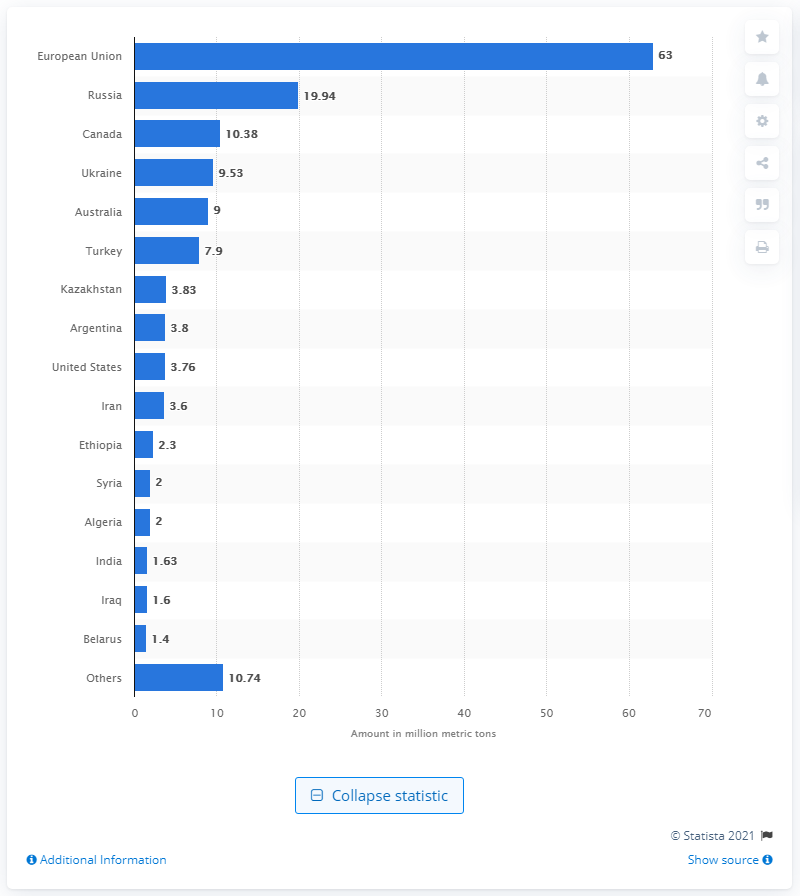Highlight a few significant elements in this photo. In the 2019/2020 crop year, Argentina produced a total of 3.83 million metric tons of barley. 